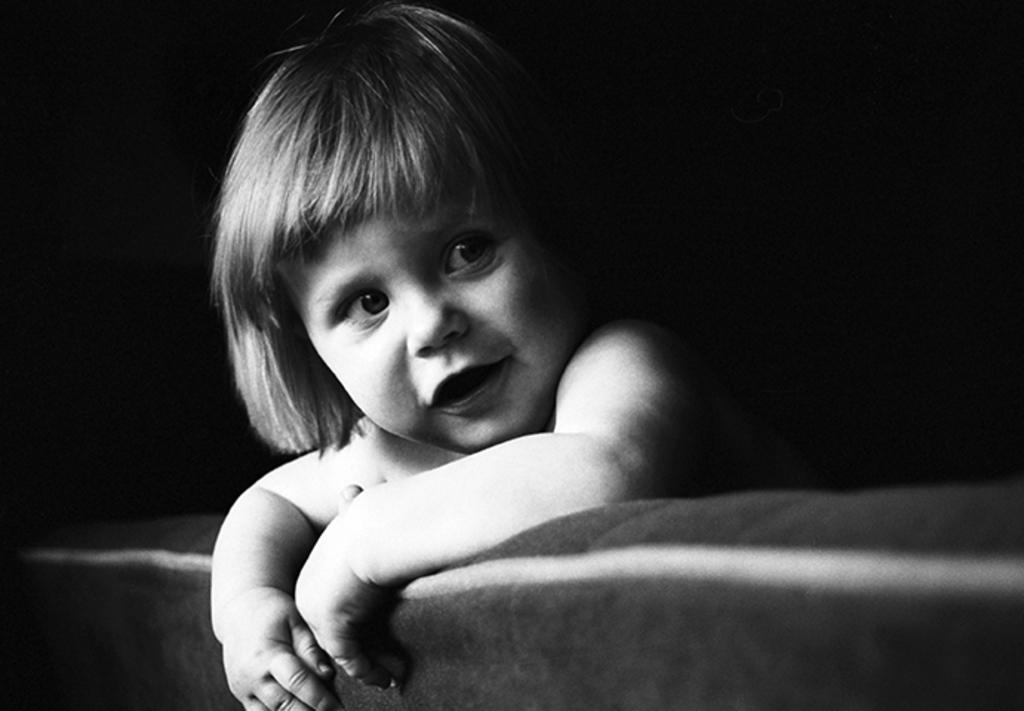What is the color scheme of the image? The image is black and white. What can be seen in the image? There is a baby in the image. What type of agreement is being signed by the goldfish in the image? There is no goldfish present in the image, and therefore no agreement being signed. 